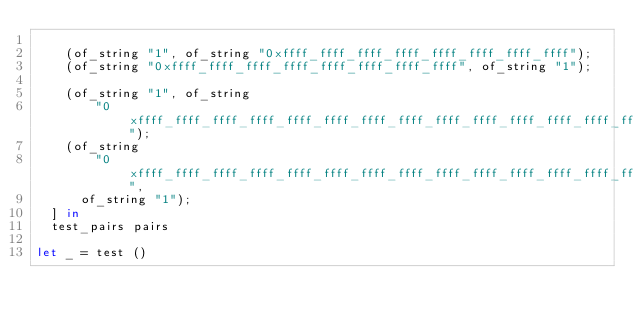<code> <loc_0><loc_0><loc_500><loc_500><_OCaml_>
    (of_string "1", of_string "0xffff_ffff_ffff_ffff_ffff_ffff_ffff_ffff");
    (of_string "0xffff_ffff_ffff_ffff_ffff_ffff_ffff_ffff", of_string "1");

    (of_string "1", of_string
        "0xffff_ffff_ffff_ffff_ffff_ffff_ffff_ffff_ffff_ffff_ffff_ffff_ffff_ffff_ffff_ffff");
    (of_string
        "0xffff_ffff_ffff_ffff_ffff_ffff_ffff_ffff_ffff_ffff_ffff_ffff_ffff_ffff_ffff_ffff",
      of_string "1");
  ] in
  test_pairs pairs

let _ = test ()
</code> 